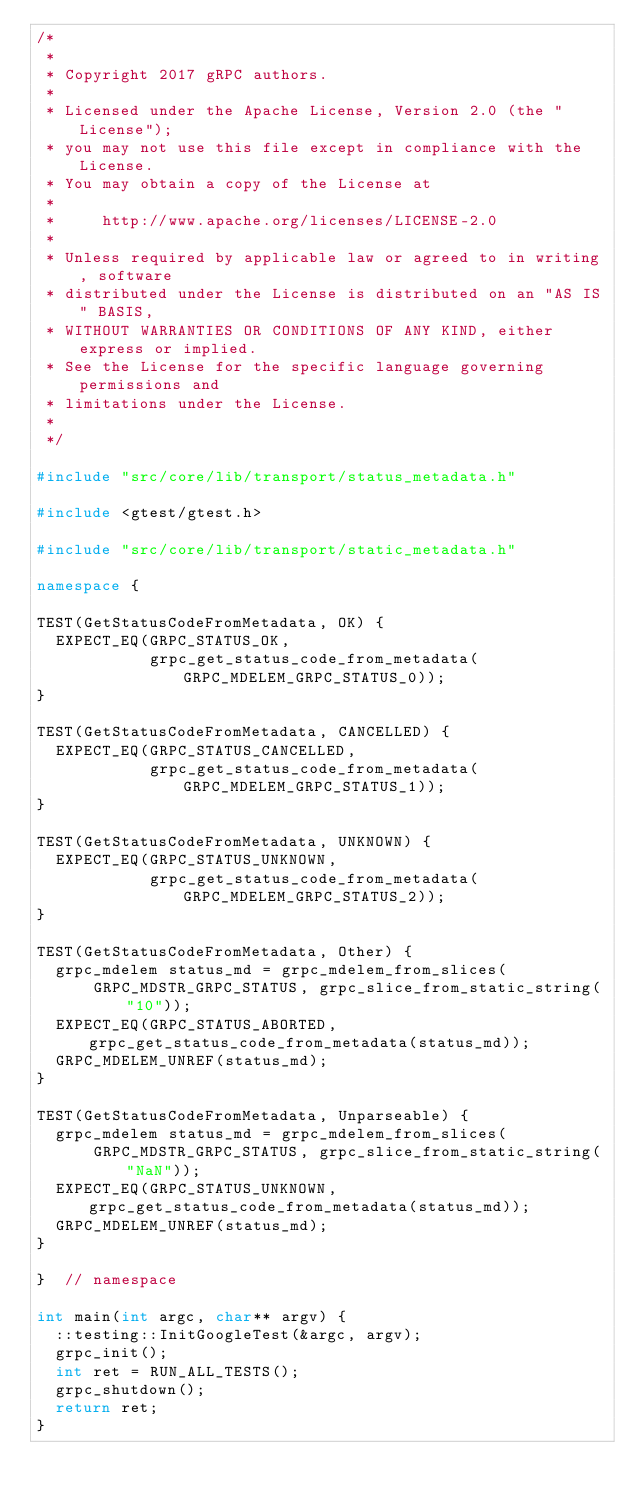Convert code to text. <code><loc_0><loc_0><loc_500><loc_500><_C++_>/*
 *
 * Copyright 2017 gRPC authors.
 *
 * Licensed under the Apache License, Version 2.0 (the "License");
 * you may not use this file except in compliance with the License.
 * You may obtain a copy of the License at
 *
 *     http://www.apache.org/licenses/LICENSE-2.0
 *
 * Unless required by applicable law or agreed to in writing, software
 * distributed under the License is distributed on an "AS IS" BASIS,
 * WITHOUT WARRANTIES OR CONDITIONS OF ANY KIND, either express or implied.
 * See the License for the specific language governing permissions and
 * limitations under the License.
 *
 */

#include "src/core/lib/transport/status_metadata.h"

#include <gtest/gtest.h>

#include "src/core/lib/transport/static_metadata.h"

namespace {

TEST(GetStatusCodeFromMetadata, OK) {
  EXPECT_EQ(GRPC_STATUS_OK,
            grpc_get_status_code_from_metadata(GRPC_MDELEM_GRPC_STATUS_0));
}

TEST(GetStatusCodeFromMetadata, CANCELLED) {
  EXPECT_EQ(GRPC_STATUS_CANCELLED,
            grpc_get_status_code_from_metadata(GRPC_MDELEM_GRPC_STATUS_1));
}

TEST(GetStatusCodeFromMetadata, UNKNOWN) {
  EXPECT_EQ(GRPC_STATUS_UNKNOWN,
            grpc_get_status_code_from_metadata(GRPC_MDELEM_GRPC_STATUS_2));
}

TEST(GetStatusCodeFromMetadata, Other) {
  grpc_mdelem status_md = grpc_mdelem_from_slices(
      GRPC_MDSTR_GRPC_STATUS, grpc_slice_from_static_string("10"));
  EXPECT_EQ(GRPC_STATUS_ABORTED, grpc_get_status_code_from_metadata(status_md));
  GRPC_MDELEM_UNREF(status_md);
}

TEST(GetStatusCodeFromMetadata, Unparseable) {
  grpc_mdelem status_md = grpc_mdelem_from_slices(
      GRPC_MDSTR_GRPC_STATUS, grpc_slice_from_static_string("NaN"));
  EXPECT_EQ(GRPC_STATUS_UNKNOWN, grpc_get_status_code_from_metadata(status_md));
  GRPC_MDELEM_UNREF(status_md);
}

}  // namespace

int main(int argc, char** argv) {
  ::testing::InitGoogleTest(&argc, argv);
  grpc_init();
  int ret = RUN_ALL_TESTS();
  grpc_shutdown();
  return ret;
}
</code> 